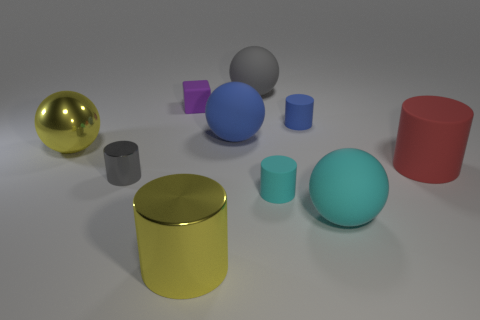Do the large cylinder that is in front of the red cylinder and the large thing to the left of the tiny purple thing have the same color?
Provide a succinct answer. Yes. What shape is the tiny rubber thing that is in front of the big rubber thing that is to the left of the matte thing that is behind the purple object?
Your answer should be compact. Cylinder. What shape is the big rubber object that is both left of the big red object and in front of the large yellow ball?
Ensure brevity in your answer.  Sphere. There is a large yellow thing behind the sphere that is in front of the large yellow sphere; what number of large yellow metallic objects are in front of it?
Give a very brief answer. 1. There is a yellow thing that is the same shape as the red rubber object; what size is it?
Ensure brevity in your answer.  Large. Is the gray object that is behind the small purple matte object made of the same material as the red cylinder?
Offer a very short reply. Yes. The other metallic object that is the same shape as the small gray shiny thing is what color?
Provide a short and direct response. Yellow. What number of other things are the same color as the large metallic cylinder?
Your answer should be very brief. 1. Is the shape of the big yellow metal thing in front of the large metal ball the same as the gray object that is in front of the big rubber cylinder?
Offer a terse response. Yes. What number of blocks are big brown shiny objects or blue things?
Your response must be concise. 0. 